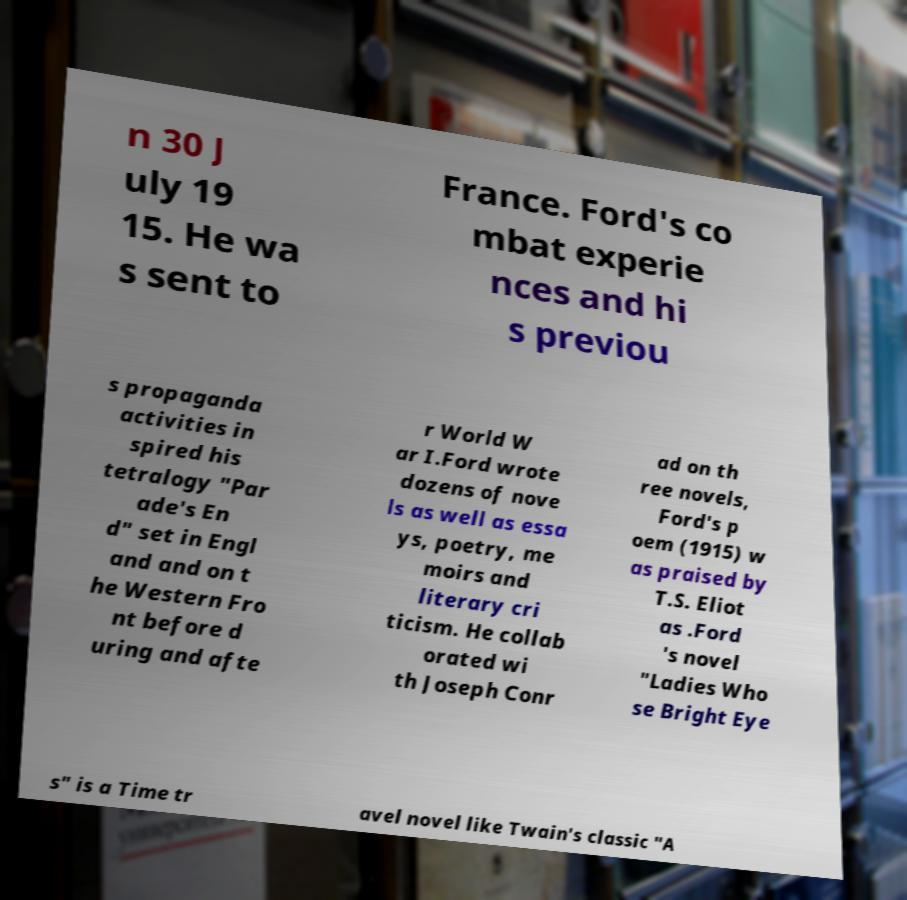Can you read and provide the text displayed in the image?This photo seems to have some interesting text. Can you extract and type it out for me? n 30 J uly 19 15. He wa s sent to France. Ford's co mbat experie nces and hi s previou s propaganda activities in spired his tetralogy "Par ade's En d" set in Engl and and on t he Western Fro nt before d uring and afte r World W ar I.Ford wrote dozens of nove ls as well as essa ys, poetry, me moirs and literary cri ticism. He collab orated wi th Joseph Conr ad on th ree novels, Ford's p oem (1915) w as praised by T.S. Eliot as .Ford 's novel "Ladies Who se Bright Eye s" is a Time tr avel novel like Twain's classic "A 